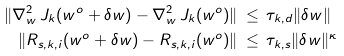Convert formula to latex. <formula><loc_0><loc_0><loc_500><loc_500>\| \nabla _ { w } ^ { 2 } \, J _ { k } ( w ^ { o } + \delta w ) - \nabla _ { w } ^ { 2 } \, J _ { k } ( w ^ { o } ) \| & \, \leq \, \tau _ { k , d } \| \delta w \| \\ \| R _ { s , k , i } ( w ^ { o } + \delta w ) - R _ { s , k , i } ( w ^ { o } ) \| & \, \leq \, \tau _ { k , s } \| \delta w \| ^ { \kappa }</formula> 